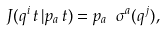Convert formula to latex. <formula><loc_0><loc_0><loc_500><loc_500>J ( q ^ { i } \, t \, | p _ { a } \, t ) = p _ { a } \ \sigma ^ { a } ( q ^ { j } ) ,</formula> 